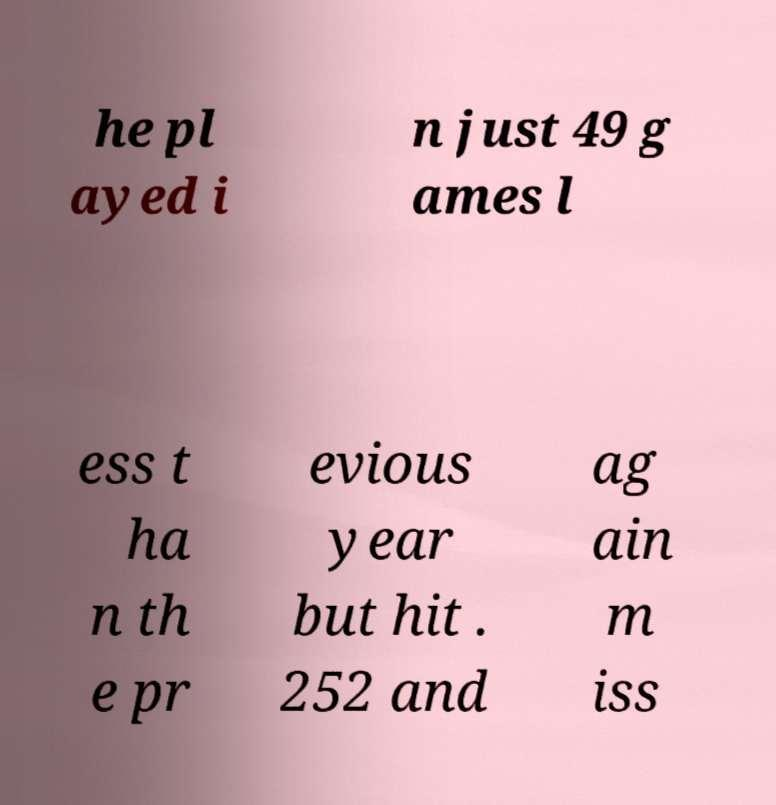I need the written content from this picture converted into text. Can you do that? he pl ayed i n just 49 g ames l ess t ha n th e pr evious year but hit . 252 and ag ain m iss 